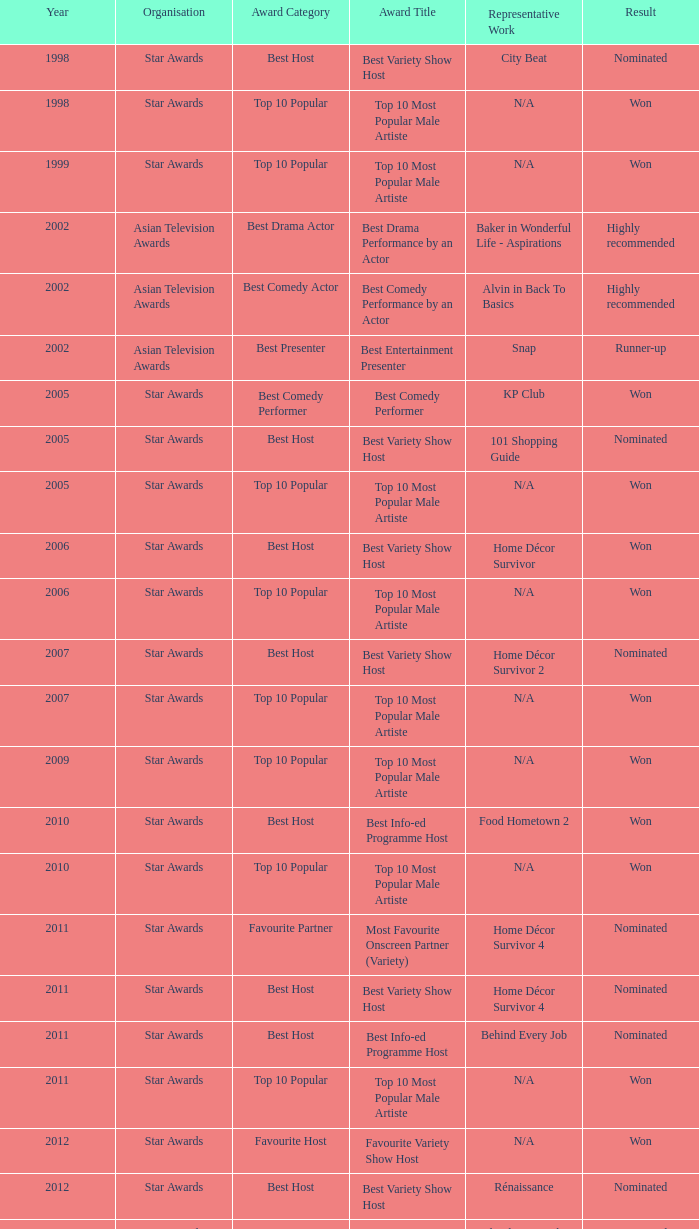What is the name of the Representative Work in a year later than 2005 with a Result of nominated, and an Award of best variety show host? Home Décor Survivor 2, Home Décor Survivor 4, Rénaissance, Jobs Around The World. 